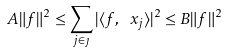Convert formula to latex. <formula><loc_0><loc_0><loc_500><loc_500>A \| f \| ^ { 2 } \leq \sum _ { j \in \jmath } | \langle f , \ x _ { j } \rangle | ^ { 2 } \leq B \| f \| ^ { 2 }</formula> 